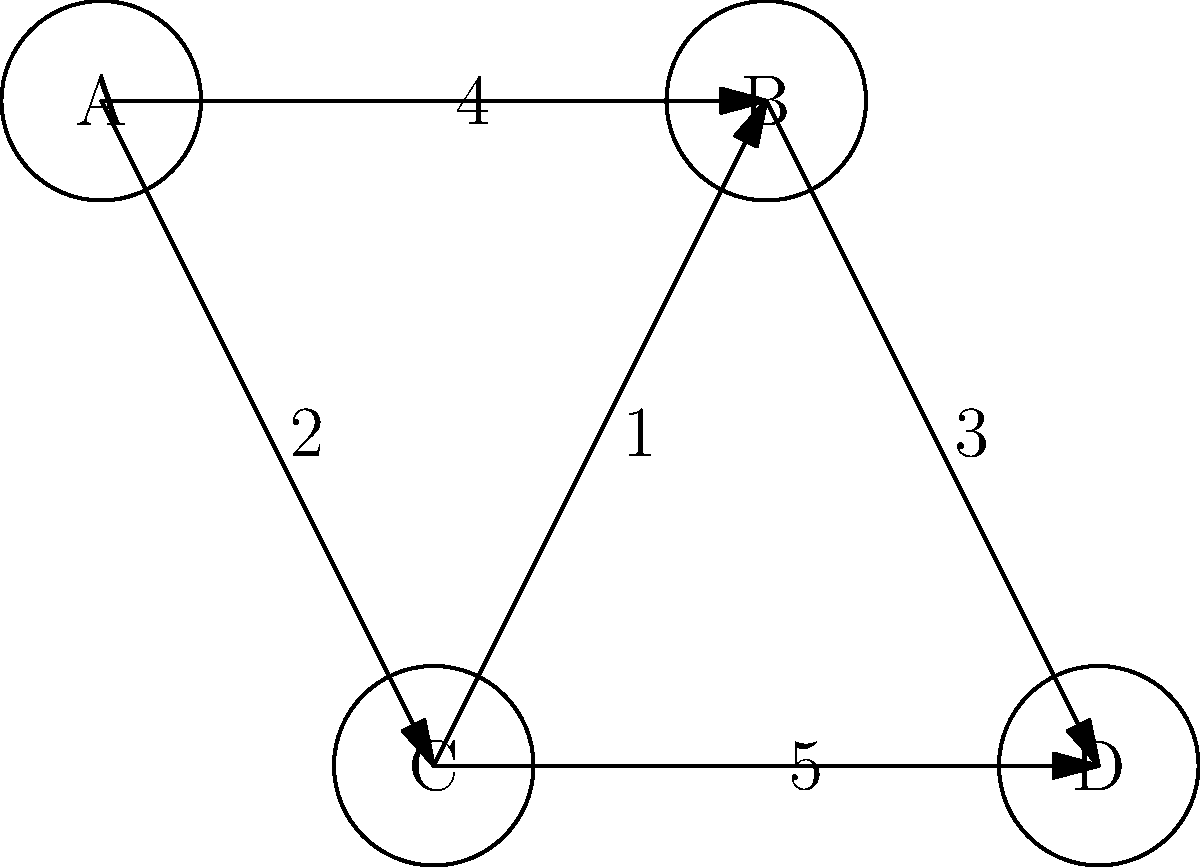In the given weighted graph, find the shortest path from node A to node D. What is the total weight of this path? To find the shortest path from A to D, we'll consider all possible paths and their total weights:

1. Path A → B → D:
   Weight = 4 + 3 = 7

2. Path A → C → D:
   Weight = 2 + 5 = 7

3. Path A → C → B → D:
   Weight = 2 + 1 + 3 = 6

The shortest path is A → C → B → D with a total weight of 6.

Step-by-step explanation:
1. Start at node A.
2. Move to node C (weight 2).
3. From C, move to B (weight 1).
4. Finally, move from B to D (weight 3).
5. Sum up the weights: 2 + 1 + 3 = 6.

This path utilizes the shorter connection between C and B, which allows for a more efficient route to D compared to the direct paths.
Answer: 6 